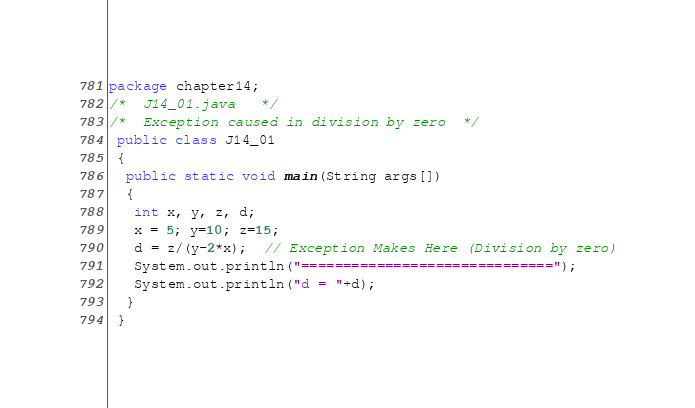Convert code to text. <code><loc_0><loc_0><loc_500><loc_500><_Java_>package chapter14;
/*  J14_01.java   */
/*  Exception caused in division by zero  */
 public class J14_01
 {
  public static void main(String args[])
  {
   int x, y, z, d;
   x = 5; y=10; z=15;
   d = z/(y-2*x);  // Exception Makes Here (Division by zero)
   System.out.println("==============================");
   System.out.println("d = "+d);
  }
 }
</code> 